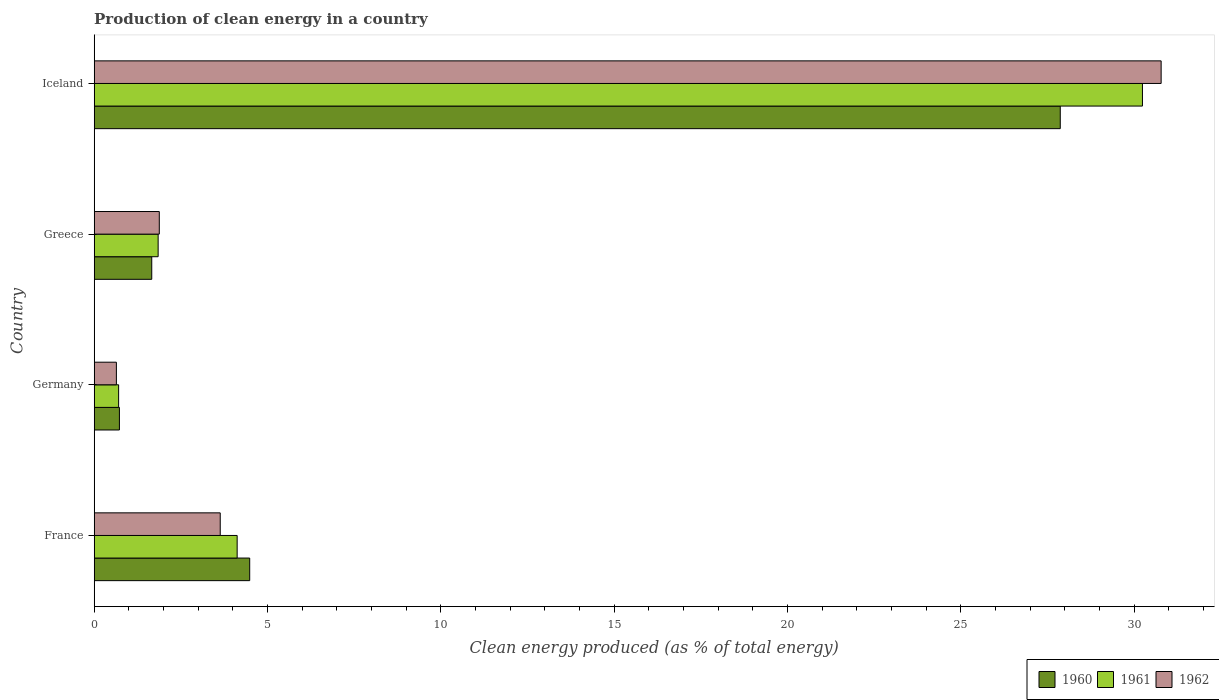How many groups of bars are there?
Ensure brevity in your answer.  4. How many bars are there on the 2nd tick from the bottom?
Provide a succinct answer. 3. What is the label of the 1st group of bars from the top?
Your answer should be very brief. Iceland. What is the percentage of clean energy produced in 1961 in France?
Offer a terse response. 4.12. Across all countries, what is the maximum percentage of clean energy produced in 1962?
Make the answer very short. 30.78. Across all countries, what is the minimum percentage of clean energy produced in 1960?
Give a very brief answer. 0.73. In which country was the percentage of clean energy produced in 1961 maximum?
Your response must be concise. Iceland. In which country was the percentage of clean energy produced in 1961 minimum?
Offer a terse response. Germany. What is the total percentage of clean energy produced in 1960 in the graph?
Provide a short and direct response. 34.75. What is the difference between the percentage of clean energy produced in 1962 in France and that in Iceland?
Offer a terse response. -27.15. What is the difference between the percentage of clean energy produced in 1960 in Germany and the percentage of clean energy produced in 1962 in Iceland?
Give a very brief answer. -30.05. What is the average percentage of clean energy produced in 1961 per country?
Your answer should be compact. 9.23. What is the difference between the percentage of clean energy produced in 1961 and percentage of clean energy produced in 1960 in Germany?
Give a very brief answer. -0.02. In how many countries, is the percentage of clean energy produced in 1962 greater than 27 %?
Provide a succinct answer. 1. What is the ratio of the percentage of clean energy produced in 1960 in Germany to that in Greece?
Keep it short and to the point. 0.44. Is the percentage of clean energy produced in 1962 in Germany less than that in Iceland?
Keep it short and to the point. Yes. What is the difference between the highest and the second highest percentage of clean energy produced in 1962?
Provide a short and direct response. 27.15. What is the difference between the highest and the lowest percentage of clean energy produced in 1961?
Your answer should be very brief. 29.54. In how many countries, is the percentage of clean energy produced in 1962 greater than the average percentage of clean energy produced in 1962 taken over all countries?
Your answer should be very brief. 1. What does the 3rd bar from the bottom in Germany represents?
Make the answer very short. 1962. How many bars are there?
Offer a very short reply. 12. How many countries are there in the graph?
Make the answer very short. 4. What is the difference between two consecutive major ticks on the X-axis?
Your answer should be compact. 5. Are the values on the major ticks of X-axis written in scientific E-notation?
Offer a very short reply. No. Does the graph contain any zero values?
Make the answer very short. No. Where does the legend appear in the graph?
Provide a succinct answer. Bottom right. How many legend labels are there?
Offer a terse response. 3. How are the legend labels stacked?
Offer a terse response. Horizontal. What is the title of the graph?
Keep it short and to the point. Production of clean energy in a country. What is the label or title of the X-axis?
Keep it short and to the point. Clean energy produced (as % of total energy). What is the label or title of the Y-axis?
Offer a very short reply. Country. What is the Clean energy produced (as % of total energy) of 1960 in France?
Make the answer very short. 4.49. What is the Clean energy produced (as % of total energy) in 1961 in France?
Provide a short and direct response. 4.12. What is the Clean energy produced (as % of total energy) in 1962 in France?
Your answer should be compact. 3.64. What is the Clean energy produced (as % of total energy) of 1960 in Germany?
Give a very brief answer. 0.73. What is the Clean energy produced (as % of total energy) of 1961 in Germany?
Your answer should be very brief. 0.7. What is the Clean energy produced (as % of total energy) in 1962 in Germany?
Make the answer very short. 0.64. What is the Clean energy produced (as % of total energy) of 1960 in Greece?
Provide a short and direct response. 1.66. What is the Clean energy produced (as % of total energy) in 1961 in Greece?
Offer a very short reply. 1.84. What is the Clean energy produced (as % of total energy) of 1962 in Greece?
Provide a succinct answer. 1.88. What is the Clean energy produced (as % of total energy) of 1960 in Iceland?
Give a very brief answer. 27.87. What is the Clean energy produced (as % of total energy) in 1961 in Iceland?
Provide a succinct answer. 30.24. What is the Clean energy produced (as % of total energy) of 1962 in Iceland?
Your answer should be very brief. 30.78. Across all countries, what is the maximum Clean energy produced (as % of total energy) in 1960?
Your answer should be very brief. 27.87. Across all countries, what is the maximum Clean energy produced (as % of total energy) of 1961?
Make the answer very short. 30.24. Across all countries, what is the maximum Clean energy produced (as % of total energy) in 1962?
Your answer should be compact. 30.78. Across all countries, what is the minimum Clean energy produced (as % of total energy) of 1960?
Offer a terse response. 0.73. Across all countries, what is the minimum Clean energy produced (as % of total energy) of 1961?
Give a very brief answer. 0.7. Across all countries, what is the minimum Clean energy produced (as % of total energy) in 1962?
Give a very brief answer. 0.64. What is the total Clean energy produced (as % of total energy) of 1960 in the graph?
Keep it short and to the point. 34.75. What is the total Clean energy produced (as % of total energy) in 1961 in the graph?
Provide a short and direct response. 36.92. What is the total Clean energy produced (as % of total energy) in 1962 in the graph?
Give a very brief answer. 36.94. What is the difference between the Clean energy produced (as % of total energy) in 1960 in France and that in Germany?
Ensure brevity in your answer.  3.76. What is the difference between the Clean energy produced (as % of total energy) in 1961 in France and that in Germany?
Your answer should be very brief. 3.42. What is the difference between the Clean energy produced (as % of total energy) in 1962 in France and that in Germany?
Offer a terse response. 3. What is the difference between the Clean energy produced (as % of total energy) of 1960 in France and that in Greece?
Provide a short and direct response. 2.83. What is the difference between the Clean energy produced (as % of total energy) of 1961 in France and that in Greece?
Your response must be concise. 2.28. What is the difference between the Clean energy produced (as % of total energy) in 1962 in France and that in Greece?
Make the answer very short. 1.76. What is the difference between the Clean energy produced (as % of total energy) in 1960 in France and that in Iceland?
Ensure brevity in your answer.  -23.39. What is the difference between the Clean energy produced (as % of total energy) of 1961 in France and that in Iceland?
Give a very brief answer. -26.12. What is the difference between the Clean energy produced (as % of total energy) of 1962 in France and that in Iceland?
Provide a short and direct response. -27.15. What is the difference between the Clean energy produced (as % of total energy) in 1960 in Germany and that in Greece?
Your answer should be compact. -0.93. What is the difference between the Clean energy produced (as % of total energy) of 1961 in Germany and that in Greece?
Your response must be concise. -1.14. What is the difference between the Clean energy produced (as % of total energy) of 1962 in Germany and that in Greece?
Ensure brevity in your answer.  -1.24. What is the difference between the Clean energy produced (as % of total energy) of 1960 in Germany and that in Iceland?
Ensure brevity in your answer.  -27.14. What is the difference between the Clean energy produced (as % of total energy) in 1961 in Germany and that in Iceland?
Your answer should be compact. -29.54. What is the difference between the Clean energy produced (as % of total energy) in 1962 in Germany and that in Iceland?
Ensure brevity in your answer.  -30.14. What is the difference between the Clean energy produced (as % of total energy) of 1960 in Greece and that in Iceland?
Your answer should be compact. -26.21. What is the difference between the Clean energy produced (as % of total energy) of 1961 in Greece and that in Iceland?
Your answer should be compact. -28.4. What is the difference between the Clean energy produced (as % of total energy) in 1962 in Greece and that in Iceland?
Provide a short and direct response. -28.9. What is the difference between the Clean energy produced (as % of total energy) of 1960 in France and the Clean energy produced (as % of total energy) of 1961 in Germany?
Give a very brief answer. 3.78. What is the difference between the Clean energy produced (as % of total energy) in 1960 in France and the Clean energy produced (as % of total energy) in 1962 in Germany?
Your answer should be very brief. 3.85. What is the difference between the Clean energy produced (as % of total energy) in 1961 in France and the Clean energy produced (as % of total energy) in 1962 in Germany?
Provide a succinct answer. 3.48. What is the difference between the Clean energy produced (as % of total energy) in 1960 in France and the Clean energy produced (as % of total energy) in 1961 in Greece?
Make the answer very short. 2.64. What is the difference between the Clean energy produced (as % of total energy) of 1960 in France and the Clean energy produced (as % of total energy) of 1962 in Greece?
Keep it short and to the point. 2.61. What is the difference between the Clean energy produced (as % of total energy) in 1961 in France and the Clean energy produced (as % of total energy) in 1962 in Greece?
Keep it short and to the point. 2.25. What is the difference between the Clean energy produced (as % of total energy) in 1960 in France and the Clean energy produced (as % of total energy) in 1961 in Iceland?
Offer a very short reply. -25.76. What is the difference between the Clean energy produced (as % of total energy) in 1960 in France and the Clean energy produced (as % of total energy) in 1962 in Iceland?
Keep it short and to the point. -26.3. What is the difference between the Clean energy produced (as % of total energy) in 1961 in France and the Clean energy produced (as % of total energy) in 1962 in Iceland?
Offer a very short reply. -26.66. What is the difference between the Clean energy produced (as % of total energy) of 1960 in Germany and the Clean energy produced (as % of total energy) of 1961 in Greece?
Keep it short and to the point. -1.12. What is the difference between the Clean energy produced (as % of total energy) in 1960 in Germany and the Clean energy produced (as % of total energy) in 1962 in Greece?
Give a very brief answer. -1.15. What is the difference between the Clean energy produced (as % of total energy) in 1961 in Germany and the Clean energy produced (as % of total energy) in 1962 in Greece?
Give a very brief answer. -1.17. What is the difference between the Clean energy produced (as % of total energy) of 1960 in Germany and the Clean energy produced (as % of total energy) of 1961 in Iceland?
Your answer should be compact. -29.52. What is the difference between the Clean energy produced (as % of total energy) of 1960 in Germany and the Clean energy produced (as % of total energy) of 1962 in Iceland?
Offer a terse response. -30.05. What is the difference between the Clean energy produced (as % of total energy) in 1961 in Germany and the Clean energy produced (as % of total energy) in 1962 in Iceland?
Provide a succinct answer. -30.08. What is the difference between the Clean energy produced (as % of total energy) of 1960 in Greece and the Clean energy produced (as % of total energy) of 1961 in Iceland?
Offer a terse response. -28.58. What is the difference between the Clean energy produced (as % of total energy) in 1960 in Greece and the Clean energy produced (as % of total energy) in 1962 in Iceland?
Ensure brevity in your answer.  -29.12. What is the difference between the Clean energy produced (as % of total energy) in 1961 in Greece and the Clean energy produced (as % of total energy) in 1962 in Iceland?
Make the answer very short. -28.94. What is the average Clean energy produced (as % of total energy) in 1960 per country?
Ensure brevity in your answer.  8.69. What is the average Clean energy produced (as % of total energy) of 1961 per country?
Provide a short and direct response. 9.23. What is the average Clean energy produced (as % of total energy) of 1962 per country?
Your answer should be very brief. 9.23. What is the difference between the Clean energy produced (as % of total energy) in 1960 and Clean energy produced (as % of total energy) in 1961 in France?
Your answer should be very brief. 0.36. What is the difference between the Clean energy produced (as % of total energy) in 1960 and Clean energy produced (as % of total energy) in 1962 in France?
Offer a terse response. 0.85. What is the difference between the Clean energy produced (as % of total energy) of 1961 and Clean energy produced (as % of total energy) of 1962 in France?
Offer a very short reply. 0.49. What is the difference between the Clean energy produced (as % of total energy) of 1960 and Clean energy produced (as % of total energy) of 1961 in Germany?
Offer a very short reply. 0.02. What is the difference between the Clean energy produced (as % of total energy) of 1960 and Clean energy produced (as % of total energy) of 1962 in Germany?
Offer a terse response. 0.09. What is the difference between the Clean energy produced (as % of total energy) of 1961 and Clean energy produced (as % of total energy) of 1962 in Germany?
Provide a succinct answer. 0.06. What is the difference between the Clean energy produced (as % of total energy) of 1960 and Clean energy produced (as % of total energy) of 1961 in Greece?
Your response must be concise. -0.18. What is the difference between the Clean energy produced (as % of total energy) in 1960 and Clean energy produced (as % of total energy) in 1962 in Greece?
Offer a very short reply. -0.22. What is the difference between the Clean energy produced (as % of total energy) in 1961 and Clean energy produced (as % of total energy) in 1962 in Greece?
Your answer should be compact. -0.03. What is the difference between the Clean energy produced (as % of total energy) of 1960 and Clean energy produced (as % of total energy) of 1961 in Iceland?
Your answer should be very brief. -2.37. What is the difference between the Clean energy produced (as % of total energy) of 1960 and Clean energy produced (as % of total energy) of 1962 in Iceland?
Your response must be concise. -2.91. What is the difference between the Clean energy produced (as % of total energy) in 1961 and Clean energy produced (as % of total energy) in 1962 in Iceland?
Your answer should be very brief. -0.54. What is the ratio of the Clean energy produced (as % of total energy) of 1960 in France to that in Germany?
Provide a succinct answer. 6.16. What is the ratio of the Clean energy produced (as % of total energy) in 1961 in France to that in Germany?
Offer a very short reply. 5.85. What is the ratio of the Clean energy produced (as % of total energy) of 1962 in France to that in Germany?
Your response must be concise. 5.68. What is the ratio of the Clean energy produced (as % of total energy) of 1960 in France to that in Greece?
Your response must be concise. 2.7. What is the ratio of the Clean energy produced (as % of total energy) in 1961 in France to that in Greece?
Make the answer very short. 2.24. What is the ratio of the Clean energy produced (as % of total energy) of 1962 in France to that in Greece?
Your answer should be compact. 1.94. What is the ratio of the Clean energy produced (as % of total energy) in 1960 in France to that in Iceland?
Ensure brevity in your answer.  0.16. What is the ratio of the Clean energy produced (as % of total energy) of 1961 in France to that in Iceland?
Provide a succinct answer. 0.14. What is the ratio of the Clean energy produced (as % of total energy) of 1962 in France to that in Iceland?
Ensure brevity in your answer.  0.12. What is the ratio of the Clean energy produced (as % of total energy) in 1960 in Germany to that in Greece?
Your response must be concise. 0.44. What is the ratio of the Clean energy produced (as % of total energy) of 1961 in Germany to that in Greece?
Give a very brief answer. 0.38. What is the ratio of the Clean energy produced (as % of total energy) of 1962 in Germany to that in Greece?
Offer a terse response. 0.34. What is the ratio of the Clean energy produced (as % of total energy) in 1960 in Germany to that in Iceland?
Your answer should be compact. 0.03. What is the ratio of the Clean energy produced (as % of total energy) of 1961 in Germany to that in Iceland?
Your answer should be compact. 0.02. What is the ratio of the Clean energy produced (as % of total energy) of 1962 in Germany to that in Iceland?
Your answer should be compact. 0.02. What is the ratio of the Clean energy produced (as % of total energy) of 1960 in Greece to that in Iceland?
Make the answer very short. 0.06. What is the ratio of the Clean energy produced (as % of total energy) in 1961 in Greece to that in Iceland?
Make the answer very short. 0.06. What is the ratio of the Clean energy produced (as % of total energy) of 1962 in Greece to that in Iceland?
Provide a short and direct response. 0.06. What is the difference between the highest and the second highest Clean energy produced (as % of total energy) of 1960?
Make the answer very short. 23.39. What is the difference between the highest and the second highest Clean energy produced (as % of total energy) in 1961?
Offer a terse response. 26.12. What is the difference between the highest and the second highest Clean energy produced (as % of total energy) of 1962?
Your answer should be compact. 27.15. What is the difference between the highest and the lowest Clean energy produced (as % of total energy) in 1960?
Your answer should be compact. 27.14. What is the difference between the highest and the lowest Clean energy produced (as % of total energy) in 1961?
Provide a succinct answer. 29.54. What is the difference between the highest and the lowest Clean energy produced (as % of total energy) in 1962?
Your answer should be compact. 30.14. 